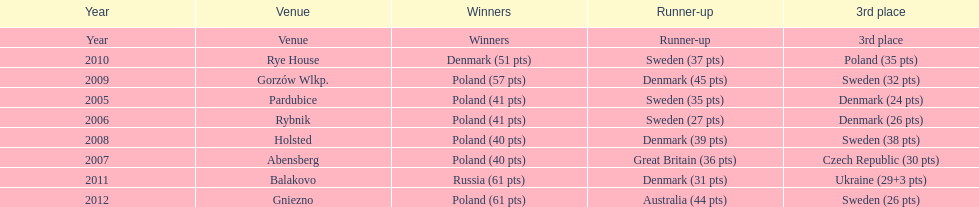After 2008 how many points total were scored by winners? 230. 